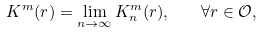Convert formula to latex. <formula><loc_0><loc_0><loc_500><loc_500>K ^ { m } ( r ) = \lim _ { n \to \infty } K _ { n } ^ { m } ( r ) , \quad \forall r \in \mathcal { O } ,</formula> 